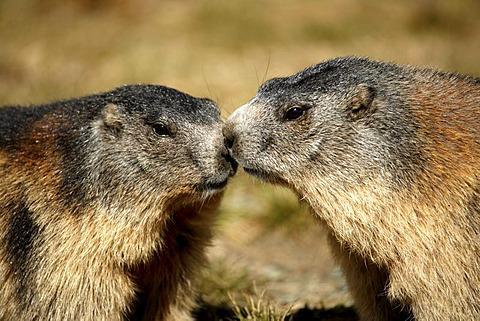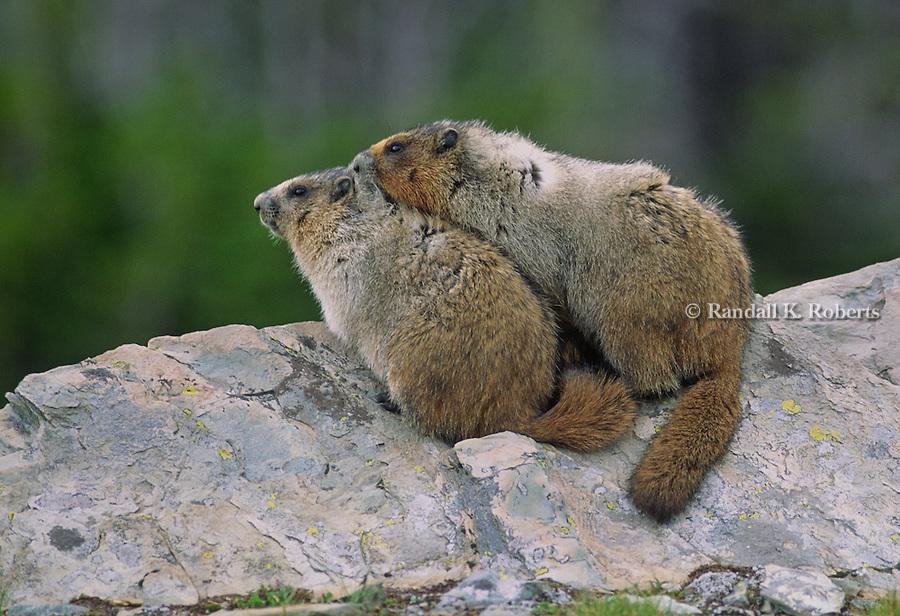The first image is the image on the left, the second image is the image on the right. Assess this claim about the two images: "Two animals in the image in the left are sitting face to face.". Correct or not? Answer yes or no. Yes. The first image is the image on the left, the second image is the image on the right. Considering the images on both sides, is "One of the images shows two groundhogs facing each other." valid? Answer yes or no. Yes. 